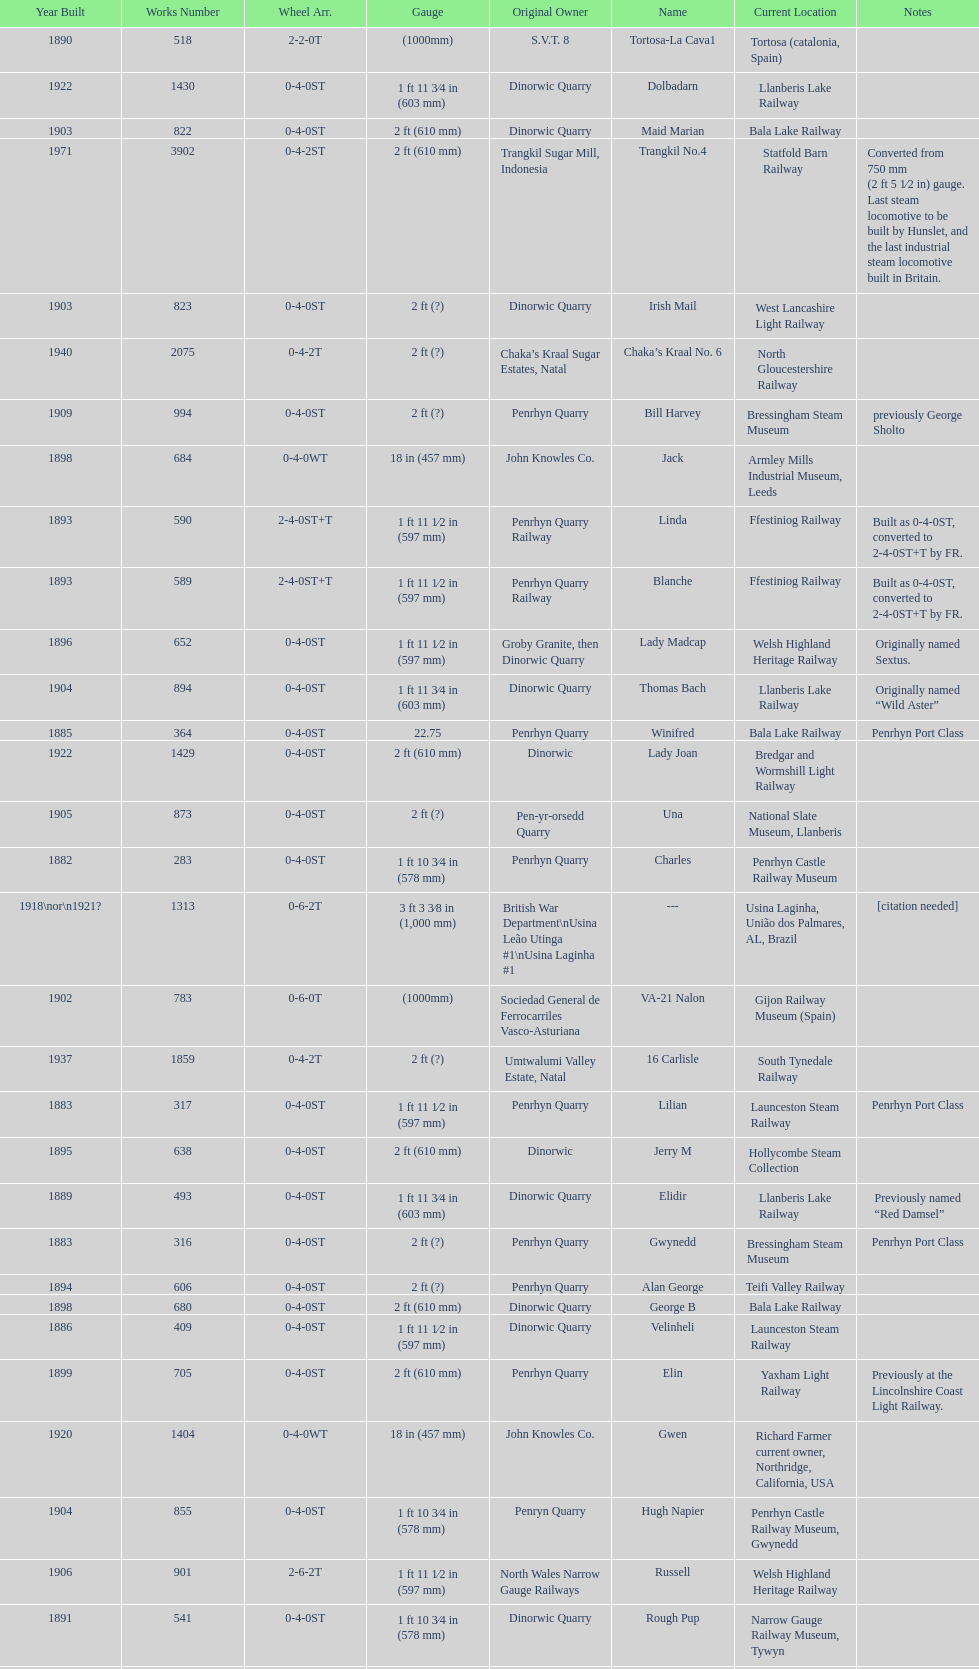In which year were the most steam locomotives built? 1898. 